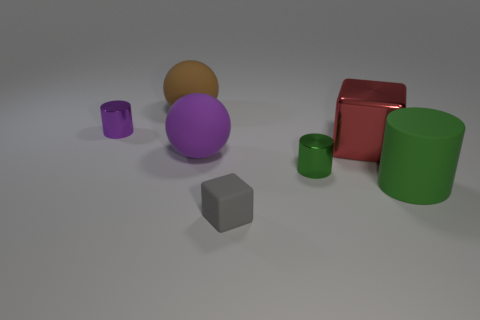Subtract all tiny metallic cylinders. How many cylinders are left? 1 Subtract 2 balls. How many balls are left? 0 Add 2 big red metal things. How many objects exist? 9 Subtract all green cylinders. How many cylinders are left? 1 Subtract all blocks. How many objects are left? 5 Subtract all blue cylinders. Subtract all purple blocks. How many cylinders are left? 3 Subtract all cyan balls. How many red blocks are left? 1 Subtract all tiny purple things. Subtract all small blue metallic blocks. How many objects are left? 6 Add 6 tiny cubes. How many tiny cubes are left? 7 Add 6 big purple metallic spheres. How many big purple metallic spheres exist? 6 